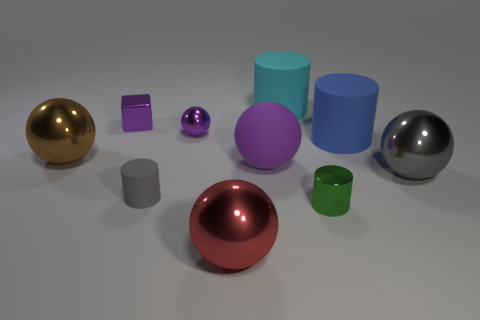Do the small sphere and the cube have the same color?
Keep it short and to the point. Yes. There is a matte object that is both to the left of the tiny shiny cylinder and behind the purple rubber object; what color is it?
Make the answer very short. Cyan. Are there any large blue objects to the right of the shiny cylinder?
Your answer should be compact. Yes. What number of small green things are in front of the purple ball in front of the large brown thing?
Give a very brief answer. 1. There is a purple sphere that is the same material as the large brown ball; what is its size?
Provide a short and direct response. Small. The gray ball has what size?
Your answer should be compact. Large. Is the material of the big gray object the same as the purple cube?
Your answer should be compact. Yes. What number of balls are either small green metallic things or large blue rubber objects?
Provide a succinct answer. 0. The rubber cylinder that is in front of the big thing that is left of the big red metal thing is what color?
Give a very brief answer. Gray. There is a rubber ball that is the same color as the metal cube; what is its size?
Give a very brief answer. Large. 